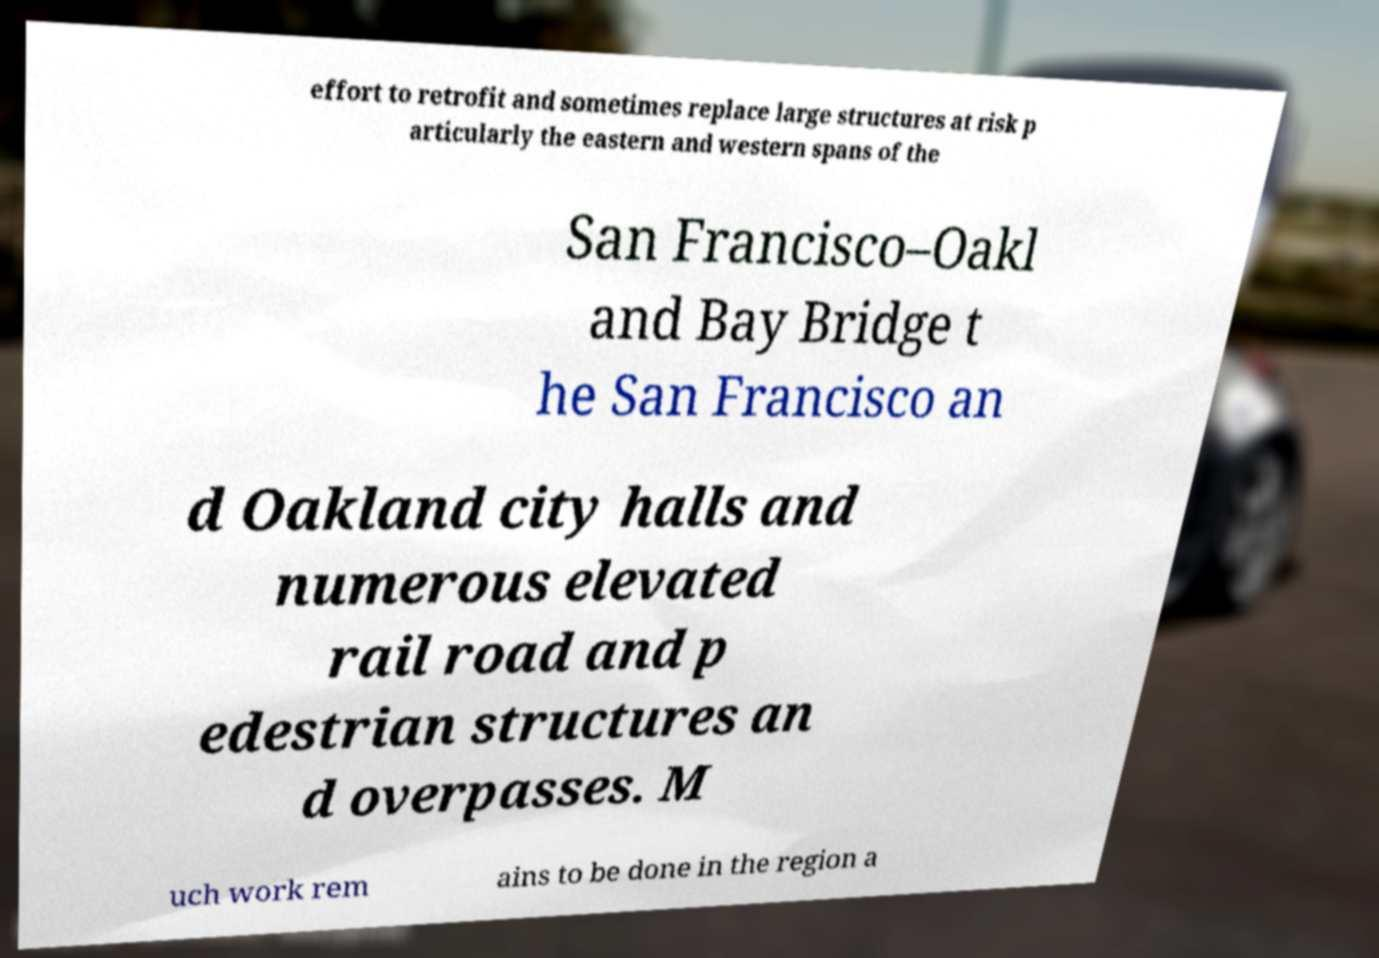What messages or text are displayed in this image? I need them in a readable, typed format. effort to retrofit and sometimes replace large structures at risk p articularly the eastern and western spans of the San Francisco–Oakl and Bay Bridge t he San Francisco an d Oakland city halls and numerous elevated rail road and p edestrian structures an d overpasses. M uch work rem ains to be done in the region a 